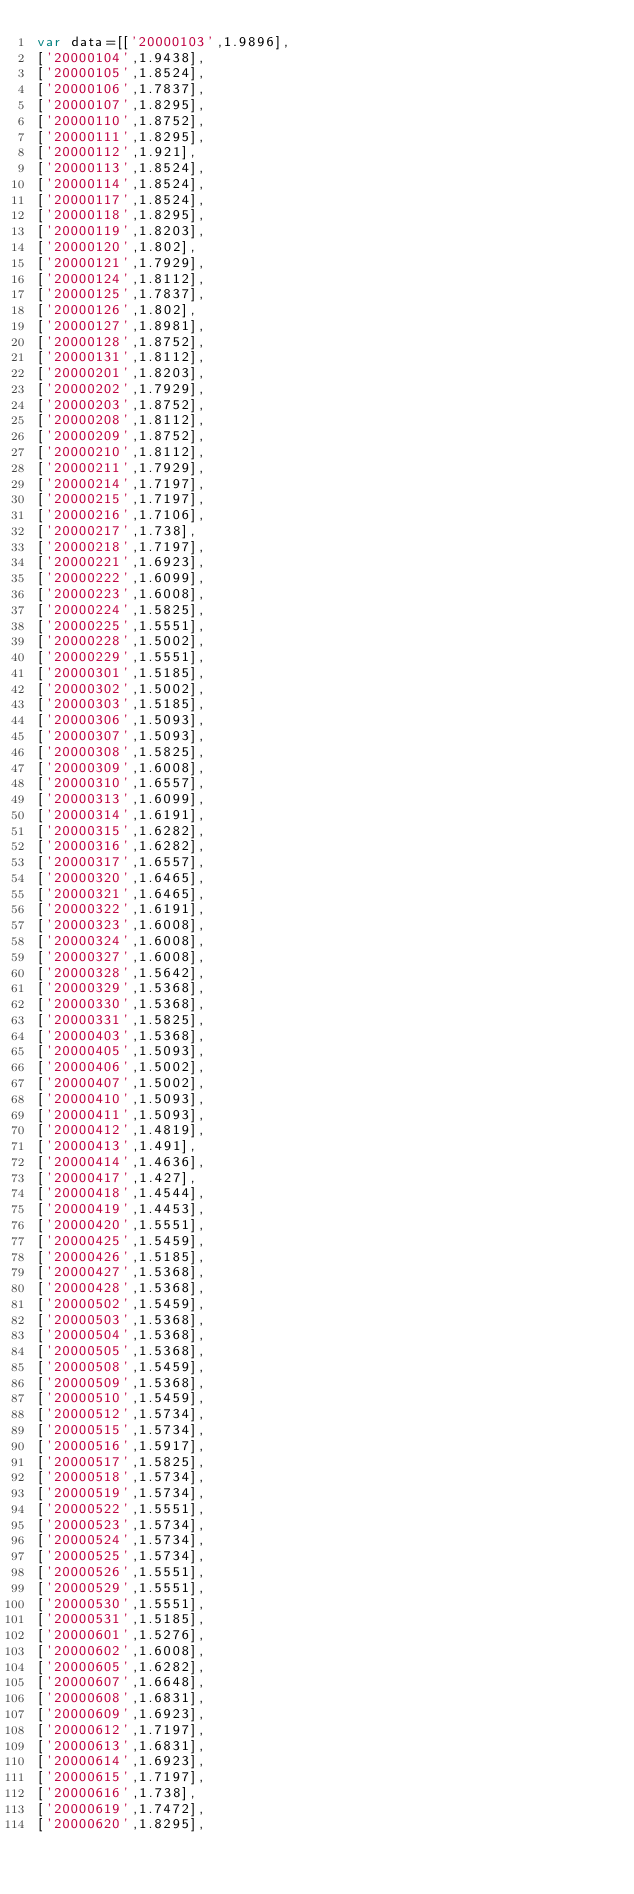Convert code to text. <code><loc_0><loc_0><loc_500><loc_500><_JavaScript_>var data=[['20000103',1.9896],
['20000104',1.9438],
['20000105',1.8524],
['20000106',1.7837],
['20000107',1.8295],
['20000110',1.8752],
['20000111',1.8295],
['20000112',1.921],
['20000113',1.8524],
['20000114',1.8524],
['20000117',1.8524],
['20000118',1.8295],
['20000119',1.8203],
['20000120',1.802],
['20000121',1.7929],
['20000124',1.8112],
['20000125',1.7837],
['20000126',1.802],
['20000127',1.8981],
['20000128',1.8752],
['20000131',1.8112],
['20000201',1.8203],
['20000202',1.7929],
['20000203',1.8752],
['20000208',1.8112],
['20000209',1.8752],
['20000210',1.8112],
['20000211',1.7929],
['20000214',1.7197],
['20000215',1.7197],
['20000216',1.7106],
['20000217',1.738],
['20000218',1.7197],
['20000221',1.6923],
['20000222',1.6099],
['20000223',1.6008],
['20000224',1.5825],
['20000225',1.5551],
['20000228',1.5002],
['20000229',1.5551],
['20000301',1.5185],
['20000302',1.5002],
['20000303',1.5185],
['20000306',1.5093],
['20000307',1.5093],
['20000308',1.5825],
['20000309',1.6008],
['20000310',1.6557],
['20000313',1.6099],
['20000314',1.6191],
['20000315',1.6282],
['20000316',1.6282],
['20000317',1.6557],
['20000320',1.6465],
['20000321',1.6465],
['20000322',1.6191],
['20000323',1.6008],
['20000324',1.6008],
['20000327',1.6008],
['20000328',1.5642],
['20000329',1.5368],
['20000330',1.5368],
['20000331',1.5825],
['20000403',1.5368],
['20000405',1.5093],
['20000406',1.5002],
['20000407',1.5002],
['20000410',1.5093],
['20000411',1.5093],
['20000412',1.4819],
['20000413',1.491],
['20000414',1.4636],
['20000417',1.427],
['20000418',1.4544],
['20000419',1.4453],
['20000420',1.5551],
['20000425',1.5459],
['20000426',1.5185],
['20000427',1.5368],
['20000428',1.5368],
['20000502',1.5459],
['20000503',1.5368],
['20000504',1.5368],
['20000505',1.5368],
['20000508',1.5459],
['20000509',1.5368],
['20000510',1.5459],
['20000512',1.5734],
['20000515',1.5734],
['20000516',1.5917],
['20000517',1.5825],
['20000518',1.5734],
['20000519',1.5734],
['20000522',1.5551],
['20000523',1.5734],
['20000524',1.5734],
['20000525',1.5734],
['20000526',1.5551],
['20000529',1.5551],
['20000530',1.5551],
['20000531',1.5185],
['20000601',1.5276],
['20000602',1.6008],
['20000605',1.6282],
['20000607',1.6648],
['20000608',1.6831],
['20000609',1.6923],
['20000612',1.7197],
['20000613',1.6831],
['20000614',1.6923],
['20000615',1.7197],
['20000616',1.738],
['20000619',1.7472],
['20000620',1.8295],</code> 